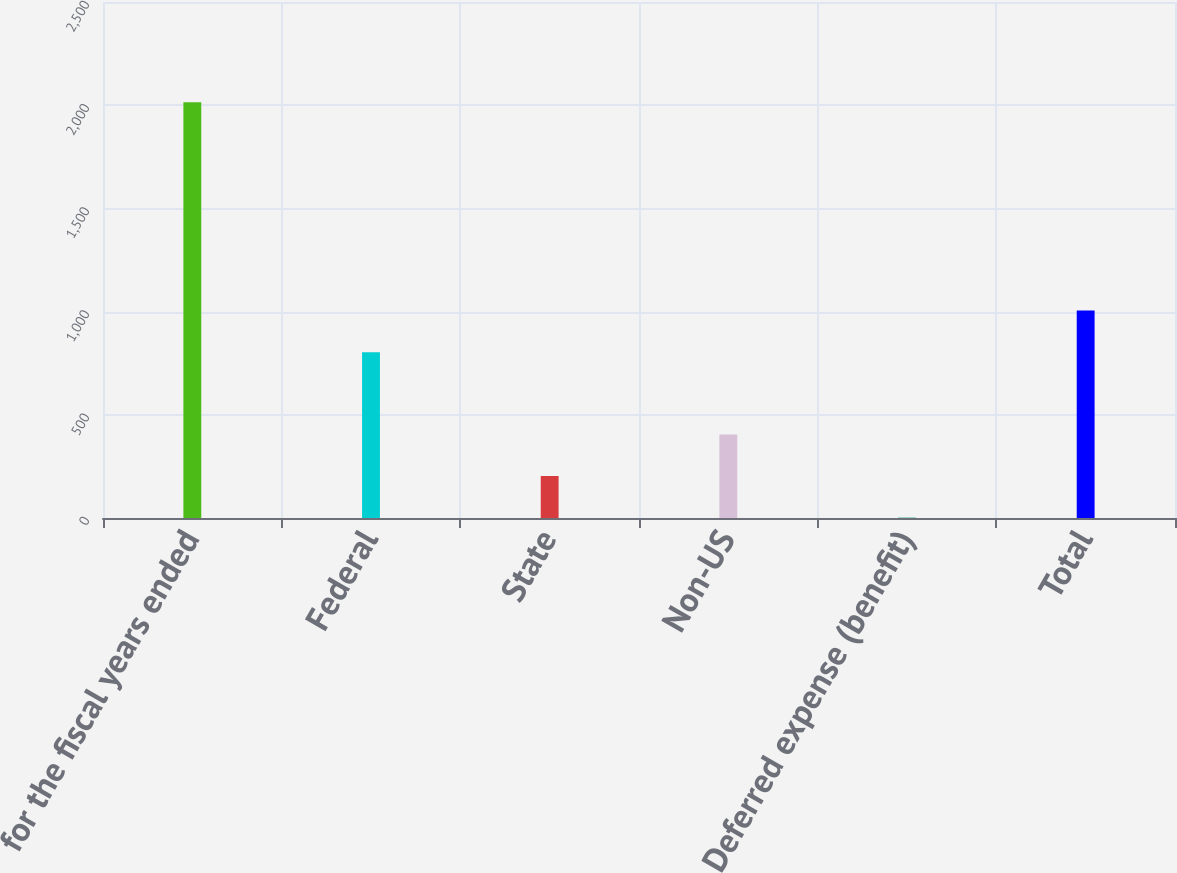<chart> <loc_0><loc_0><loc_500><loc_500><bar_chart><fcel>for the fiscal years ended<fcel>Federal<fcel>State<fcel>Non-US<fcel>Deferred expense (benefit)<fcel>Total<nl><fcel>2014<fcel>803.6<fcel>203.38<fcel>404.56<fcel>2.2<fcel>1004.78<nl></chart> 